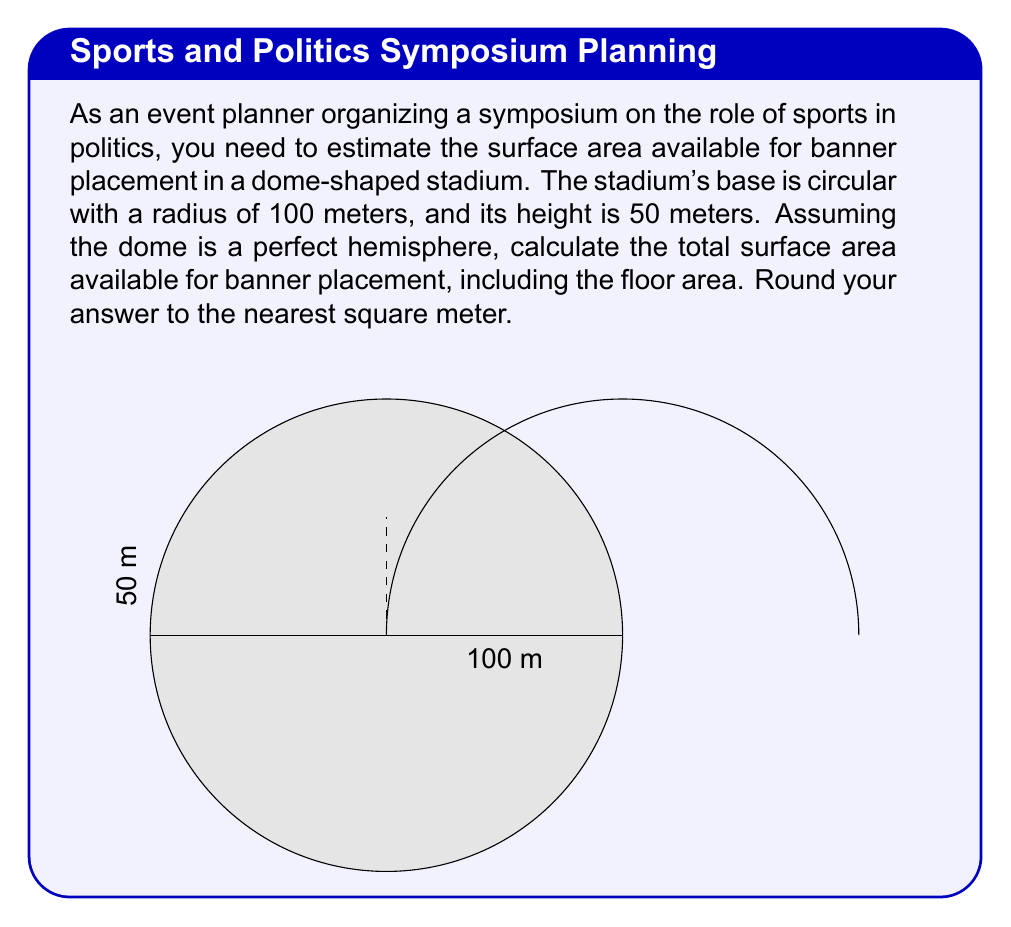Show me your answer to this math problem. Let's approach this step-by-step:

1) The stadium consists of two parts: the circular base (floor) and the hemispherical dome.

2) For the circular base:
   Area of circle = $\pi r^2$
   $A_{base} = \pi (100)^2 = 10000\pi$ m²

3) For the hemispherical dome:
   Surface area of a hemisphere = $2\pi r^2$
   $A_{dome} = 2\pi (100)^2 = 20000\pi$ m²

4) Total surface area:
   $A_{total} = A_{base} + A_{dome}$
   $A_{total} = 10000\pi + 20000\pi = 30000\pi$ m²

5) Calculate and round to the nearest square meter:
   $A_{total} = 30000\pi \approx 94248.22$ m²
   Rounded to the nearest square meter: 94248 m²

Therefore, the total surface area available for banner placement is approximately 94248 square meters.
Answer: 94248 m² 